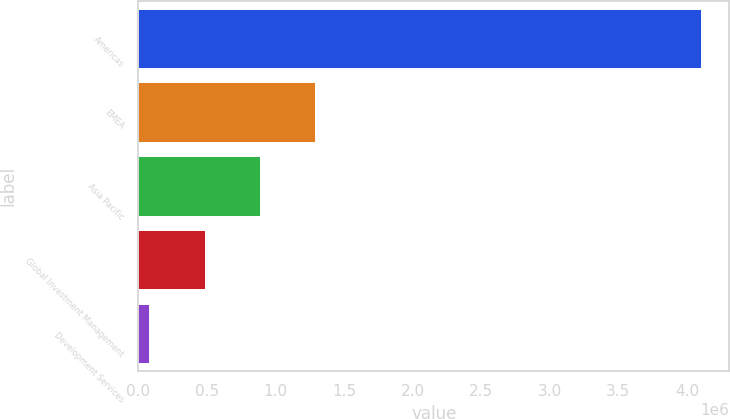<chart> <loc_0><loc_0><loc_500><loc_500><bar_chart><fcel>Americas<fcel>EMEA<fcel>Asia Pacific<fcel>Global Investment Management<fcel>Development Services<nl><fcel>4.1036e+06<fcel>1.28754e+06<fcel>885064<fcel>482589<fcel>78849<nl></chart> 